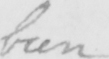Please transcribe the handwritten text in this image. been 